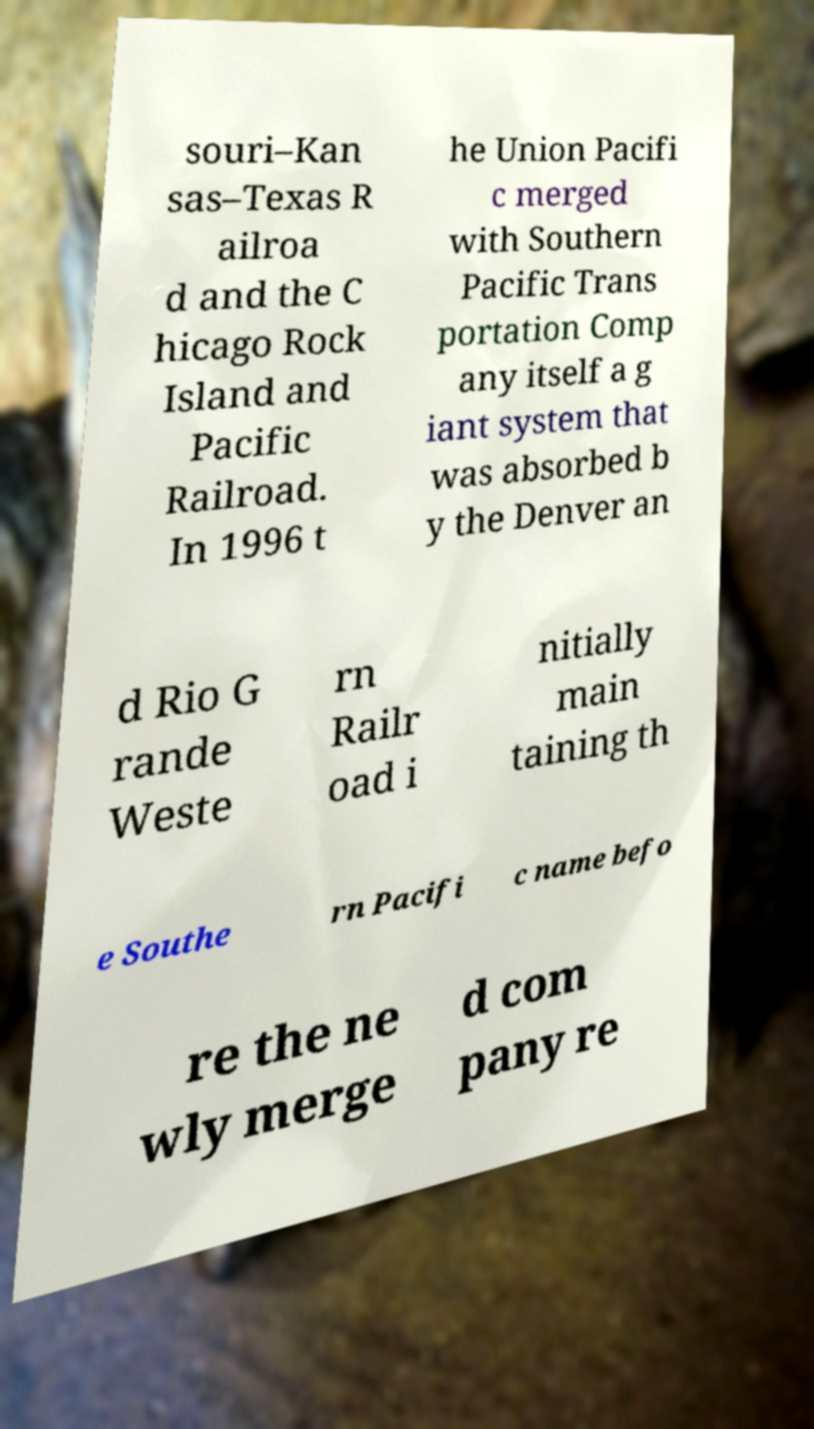What messages or text are displayed in this image? I need them in a readable, typed format. souri–Kan sas–Texas R ailroa d and the C hicago Rock Island and Pacific Railroad. In 1996 t he Union Pacifi c merged with Southern Pacific Trans portation Comp any itself a g iant system that was absorbed b y the Denver an d Rio G rande Weste rn Railr oad i nitially main taining th e Southe rn Pacifi c name befo re the ne wly merge d com pany re 